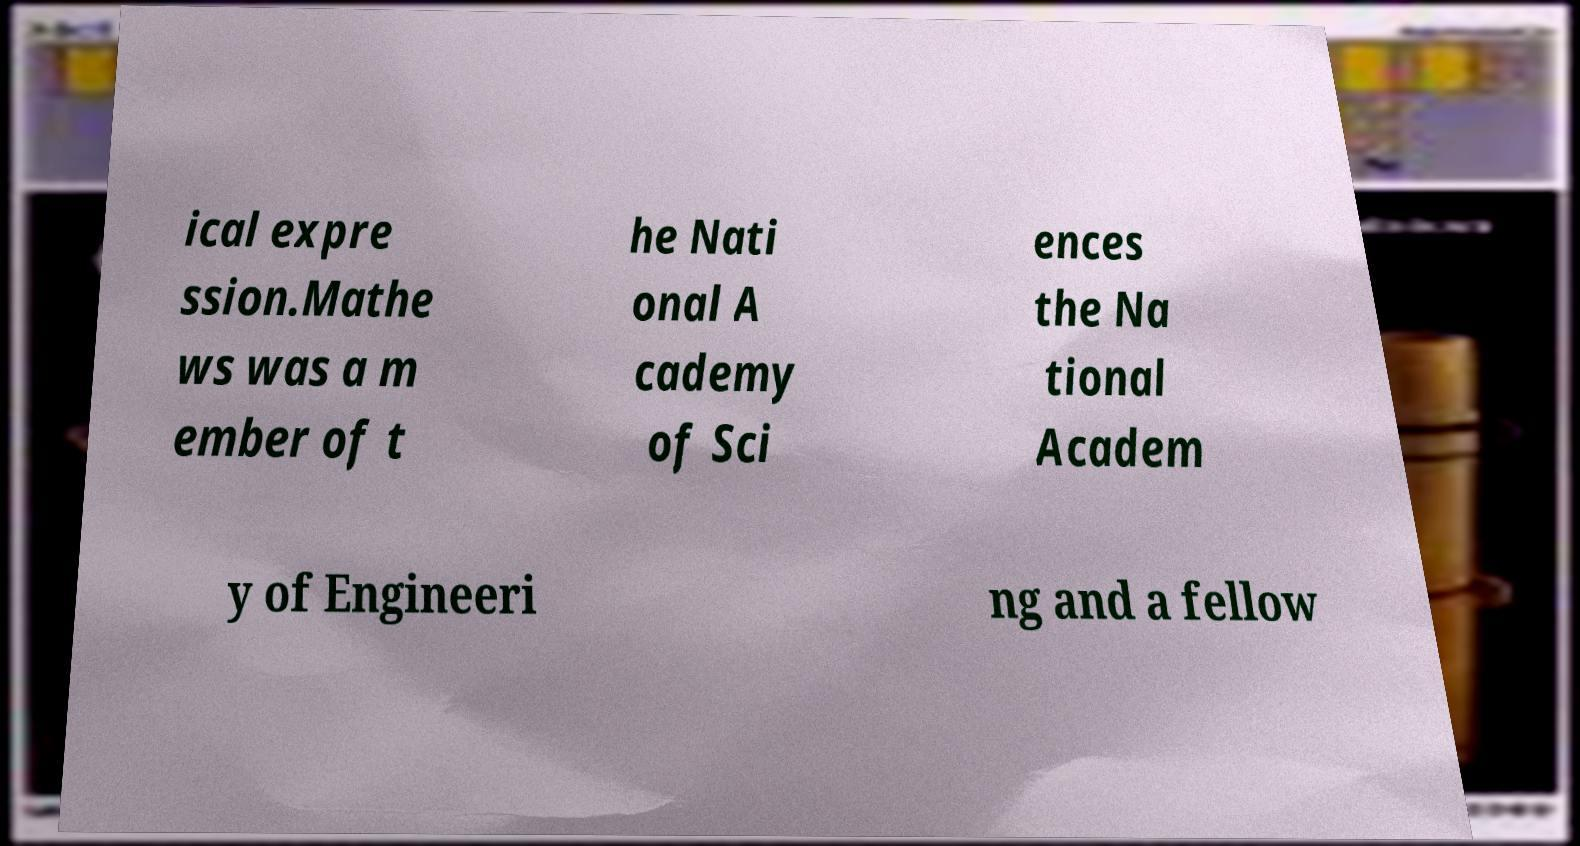For documentation purposes, I need the text within this image transcribed. Could you provide that? ical expre ssion.Mathe ws was a m ember of t he Nati onal A cademy of Sci ences the Na tional Academ y of Engineeri ng and a fellow 